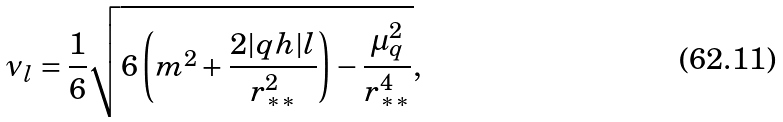Convert formula to latex. <formula><loc_0><loc_0><loc_500><loc_500>\nu _ { l } = \frac { 1 } { 6 } \sqrt { 6 \left ( m ^ { 2 } + \frac { 2 | q h | l } { r _ { * * } ^ { 2 } } \right ) - \frac { \mu _ { q } ^ { 2 } } { r _ { * * } ^ { 4 } } } ,</formula> 